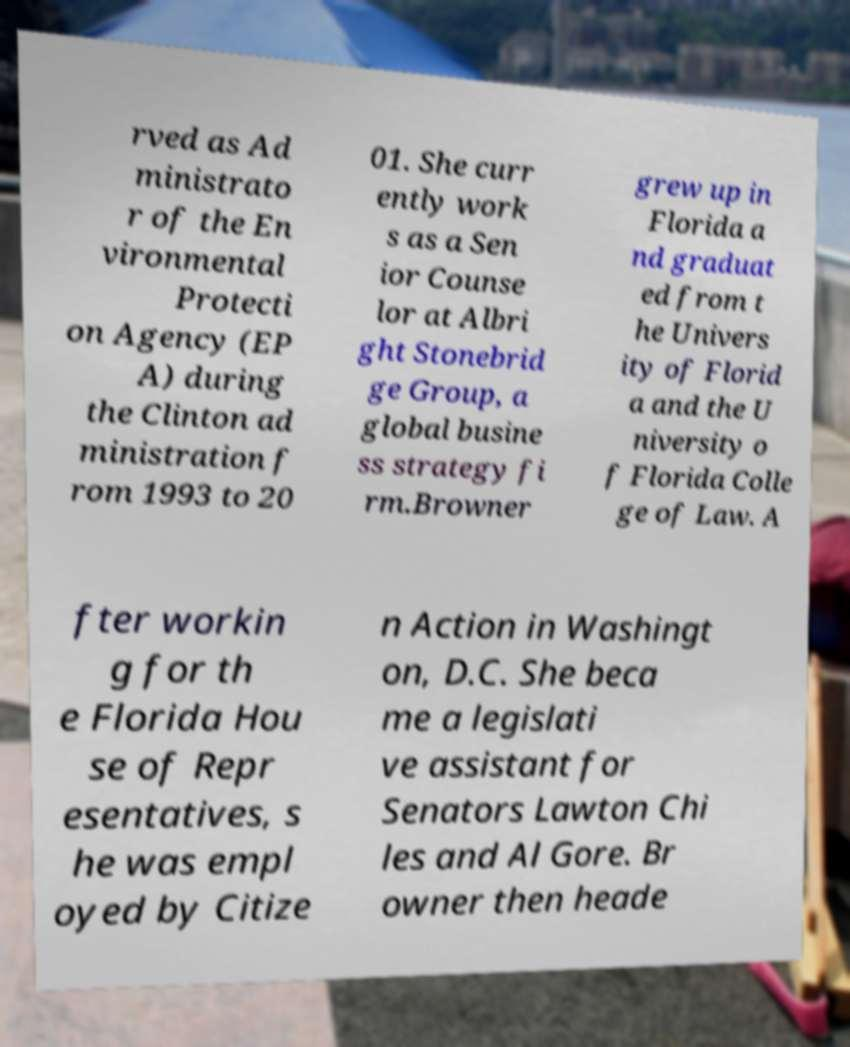Could you assist in decoding the text presented in this image and type it out clearly? rved as Ad ministrato r of the En vironmental Protecti on Agency (EP A) during the Clinton ad ministration f rom 1993 to 20 01. She curr ently work s as a Sen ior Counse lor at Albri ght Stonebrid ge Group, a global busine ss strategy fi rm.Browner grew up in Florida a nd graduat ed from t he Univers ity of Florid a and the U niversity o f Florida Colle ge of Law. A fter workin g for th e Florida Hou se of Repr esentatives, s he was empl oyed by Citize n Action in Washingt on, D.C. She beca me a legislati ve assistant for Senators Lawton Chi les and Al Gore. Br owner then heade 